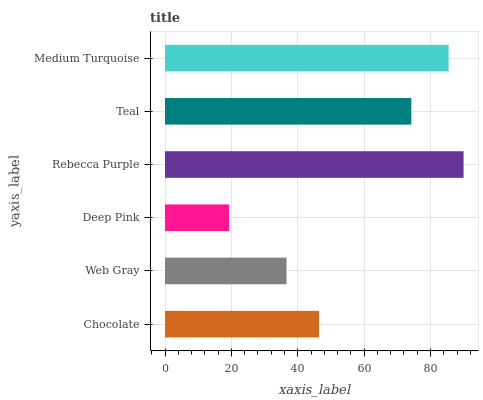Is Deep Pink the minimum?
Answer yes or no. Yes. Is Rebecca Purple the maximum?
Answer yes or no. Yes. Is Web Gray the minimum?
Answer yes or no. No. Is Web Gray the maximum?
Answer yes or no. No. Is Chocolate greater than Web Gray?
Answer yes or no. Yes. Is Web Gray less than Chocolate?
Answer yes or no. Yes. Is Web Gray greater than Chocolate?
Answer yes or no. No. Is Chocolate less than Web Gray?
Answer yes or no. No. Is Teal the high median?
Answer yes or no. Yes. Is Chocolate the low median?
Answer yes or no. Yes. Is Chocolate the high median?
Answer yes or no. No. Is Deep Pink the low median?
Answer yes or no. No. 